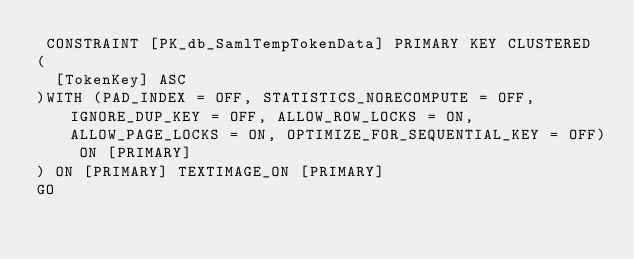Convert code to text. <code><loc_0><loc_0><loc_500><loc_500><_SQL_> CONSTRAINT [PK_db_SamlTempTokenData] PRIMARY KEY CLUSTERED 
(
	[TokenKey] ASC
)WITH (PAD_INDEX = OFF, STATISTICS_NORECOMPUTE = OFF, IGNORE_DUP_KEY = OFF, ALLOW_ROW_LOCKS = ON, ALLOW_PAGE_LOCKS = ON, OPTIMIZE_FOR_SEQUENTIAL_KEY = OFF) ON [PRIMARY]
) ON [PRIMARY] TEXTIMAGE_ON [PRIMARY]
GO


</code> 